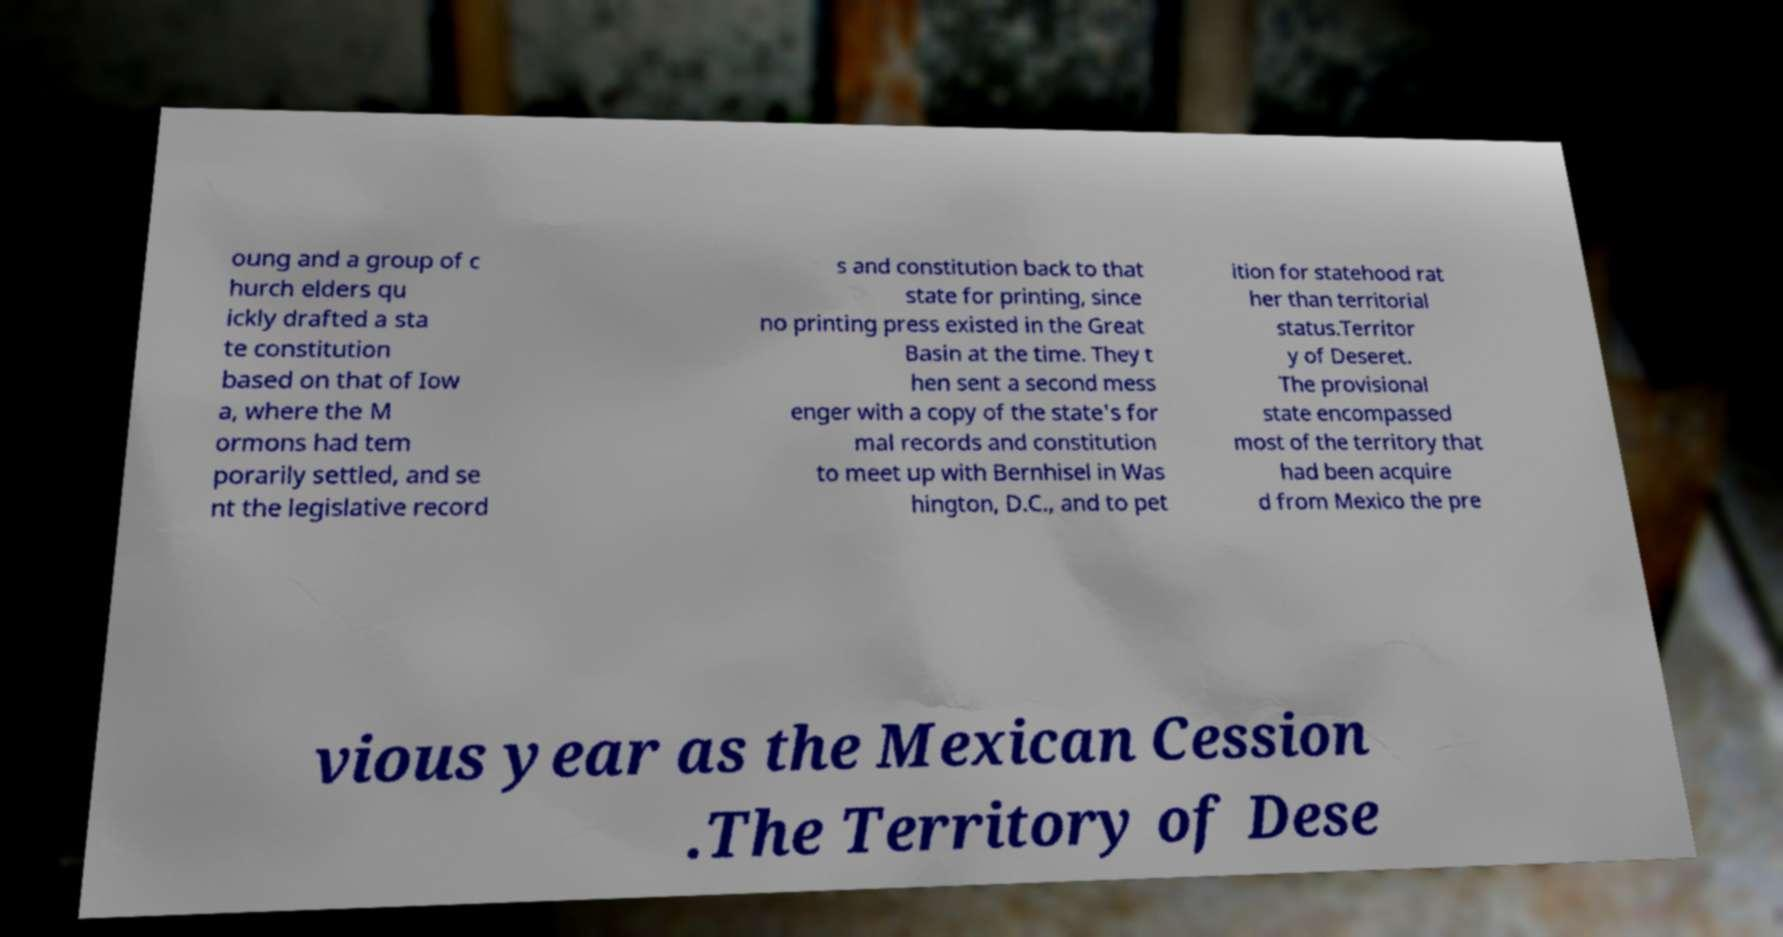Can you read and provide the text displayed in the image?This photo seems to have some interesting text. Can you extract and type it out for me? oung and a group of c hurch elders qu ickly drafted a sta te constitution based on that of Iow a, where the M ormons had tem porarily settled, and se nt the legislative record s and constitution back to that state for printing, since no printing press existed in the Great Basin at the time. They t hen sent a second mess enger with a copy of the state's for mal records and constitution to meet up with Bernhisel in Was hington, D.C., and to pet ition for statehood rat her than territorial status.Territor y of Deseret. The provisional state encompassed most of the territory that had been acquire d from Mexico the pre vious year as the Mexican Cession .The Territory of Dese 